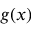<formula> <loc_0><loc_0><loc_500><loc_500>g ( x )</formula> 